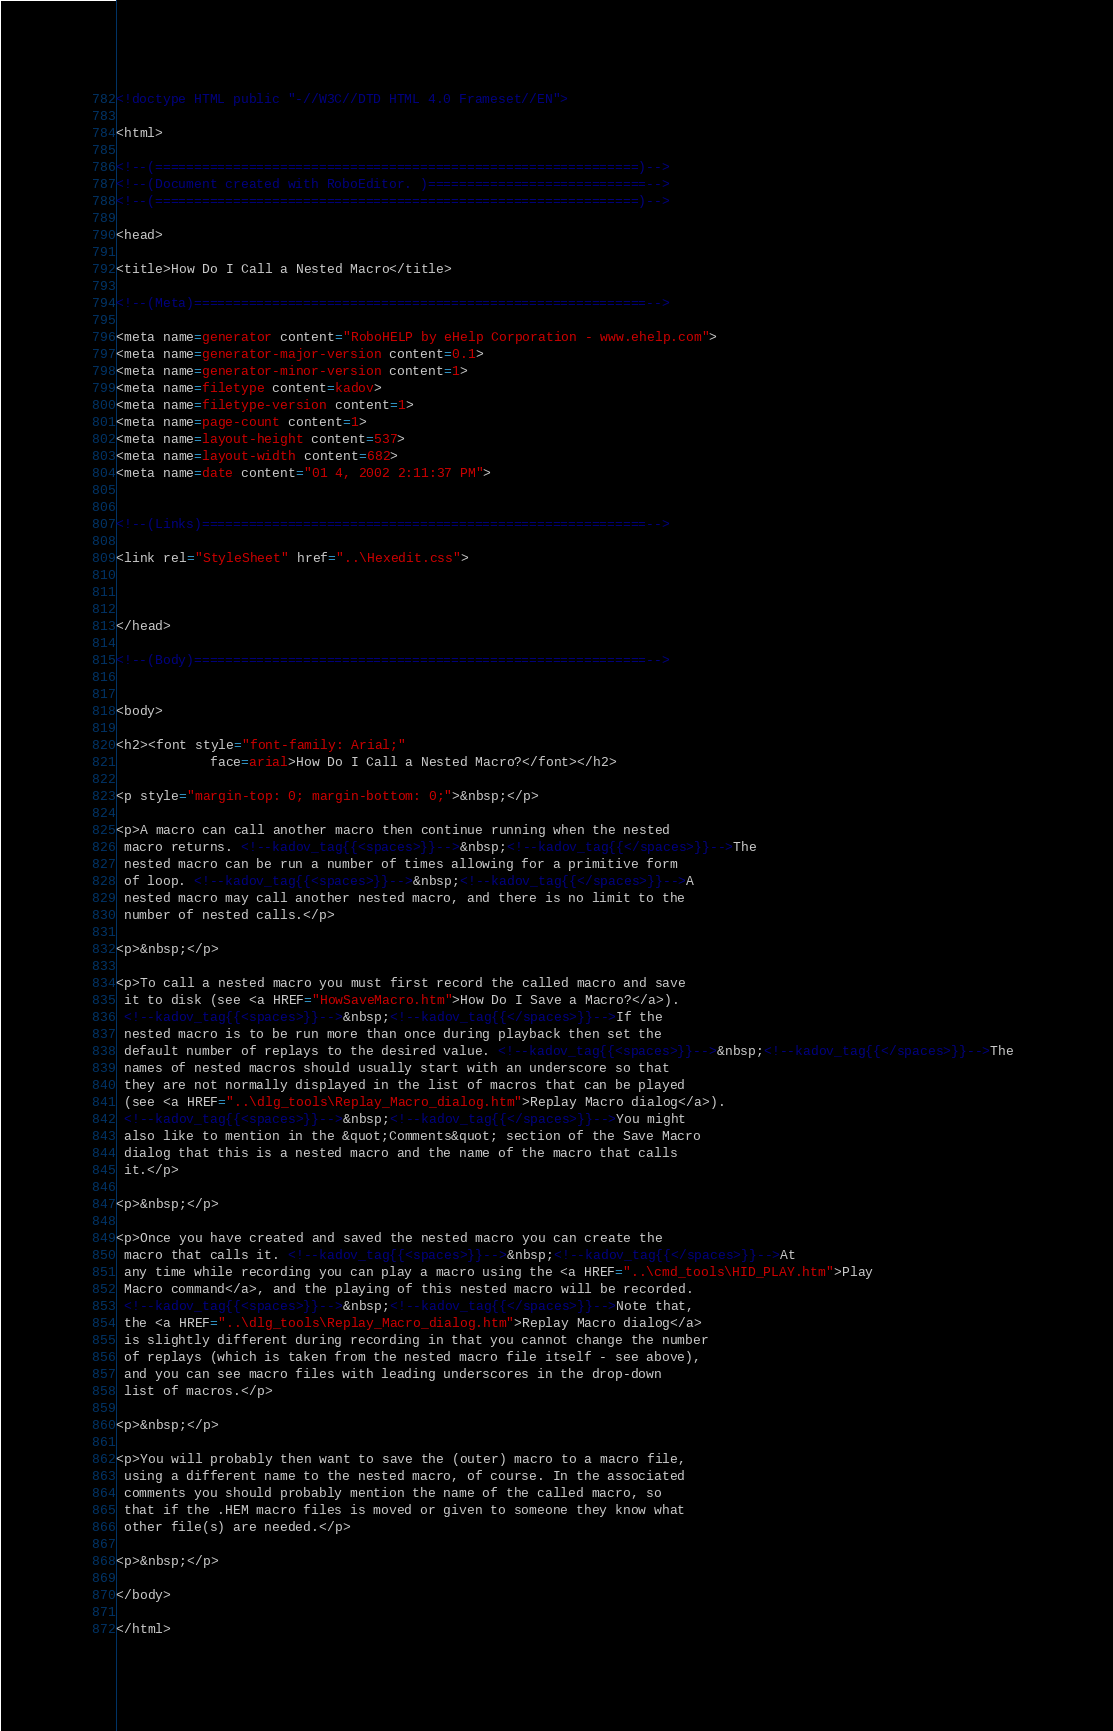Convert code to text. <code><loc_0><loc_0><loc_500><loc_500><_HTML_><!doctype HTML public "-//W3C//DTD HTML 4.0 Frameset//EN">

<html>

<!--(==============================================================)-->
<!--(Document created with RoboEditor. )============================-->
<!--(==============================================================)-->

<head>

<title>How Do I Call a Nested Macro</title>

<!--(Meta)==========================================================-->

<meta name=generator content="RoboHELP by eHelp Corporation - www.ehelp.com">
<meta name=generator-major-version content=0.1>
<meta name=generator-minor-version content=1>
<meta name=filetype content=kadov>
<meta name=filetype-version content=1>
<meta name=page-count content=1>
<meta name=layout-height content=537>
<meta name=layout-width content=682>
<meta name=date content="01 4, 2002 2:11:37 PM">


<!--(Links)=========================================================-->

<link rel="StyleSheet" href="..\Hexedit.css">



</head>

<!--(Body)==========================================================-->


<body>

<h2><font style="font-family: Arial;"
			face=arial>How Do I Call a Nested Macro?</font></h2>

<p style="margin-top: 0; margin-bottom: 0;">&nbsp;</p>

<p>A macro can call another macro then continue running when the nested 
 macro returns. <!--kadov_tag{{<spaces>}}-->&nbsp;<!--kadov_tag{{</spaces>}}-->The 
 nested macro can be run a number of times allowing for a primitive form 
 of loop. <!--kadov_tag{{<spaces>}}-->&nbsp;<!--kadov_tag{{</spaces>}}-->A 
 nested macro may call another nested macro, and there is no limit to the 
 number of nested calls.</p>

<p>&nbsp;</p>

<p>To call a nested macro you must first record the called macro and save 
 it to disk (see <a HREF="HowSaveMacro.htm">How Do I Save a Macro?</a>). 
 <!--kadov_tag{{<spaces>}}-->&nbsp;<!--kadov_tag{{</spaces>}}-->If the 
 nested macro is to be run more than once during playback then set the 
 default number of replays to the desired value. <!--kadov_tag{{<spaces>}}-->&nbsp;<!--kadov_tag{{</spaces>}}-->The 
 names of nested macros should usually start with an underscore so that 
 they are not normally displayed in the list of macros that can be played 
 (see <a HREF="..\dlg_tools\Replay_Macro_dialog.htm">Replay Macro dialog</a>). 
 <!--kadov_tag{{<spaces>}}-->&nbsp;<!--kadov_tag{{</spaces>}}-->You might 
 also like to mention in the &quot;Comments&quot; section of the Save Macro 
 dialog that this is a nested macro and the name of the macro that calls 
 it.</p>

<p>&nbsp;</p>

<p>Once you have created and saved the nested macro you can create the 
 macro that calls it. <!--kadov_tag{{<spaces>}}-->&nbsp;<!--kadov_tag{{</spaces>}}-->At 
 any time while recording you can play a macro using the <a HREF="..\cmd_tools\HID_PLAY.htm">Play 
 Macro command</a>, and the playing of this nested macro will be recorded. 
 <!--kadov_tag{{<spaces>}}-->&nbsp;<!--kadov_tag{{</spaces>}}-->Note that, 
 the <a HREF="..\dlg_tools\Replay_Macro_dialog.htm">Replay Macro dialog</a> 
 is slightly different during recording in that you cannot change the number 
 of replays (which is taken from the nested macro file itself - see above), 
 and you can see macro files with leading underscores in the drop-down 
 list of macros.</p>

<p>&nbsp;</p>

<p>You will probably then want to save the (outer) macro to a macro file, 
 using a different name to the nested macro, of course. In the associated 
 comments you should probably mention the name of the called macro, so 
 that if the .HEM macro files is moved or given to someone they know what 
 other file(s) are needed.</p>

<p>&nbsp;</p>

</body>

</html>
</code> 